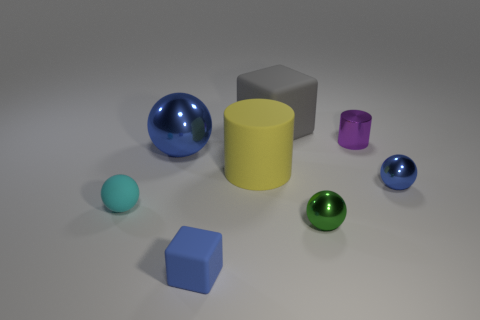Add 2 small purple shiny cylinders. How many objects exist? 10 Subtract all cylinders. How many objects are left? 6 Subtract 0 red cylinders. How many objects are left? 8 Subtract all large cubes. Subtract all large brown cylinders. How many objects are left? 7 Add 5 purple metallic cylinders. How many purple metallic cylinders are left? 6 Add 1 tiny blue matte cubes. How many tiny blue matte cubes exist? 2 